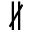<formula> <loc_0><loc_0><loc_500><loc_500>\nparallel</formula> 